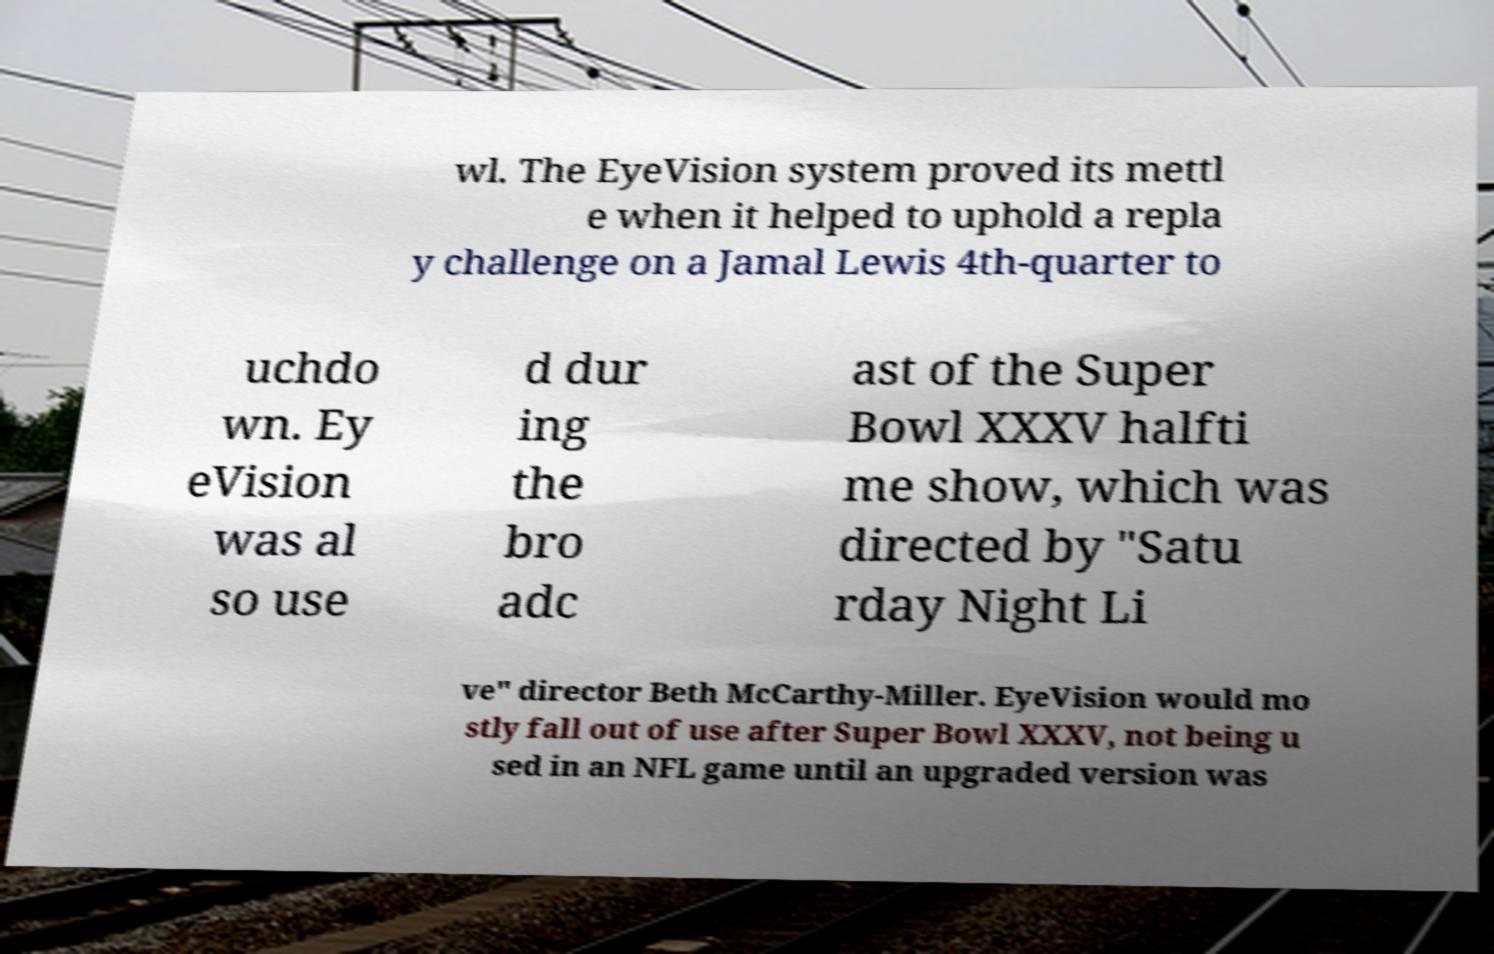Could you extract and type out the text from this image? wl. The EyeVision system proved its mettl e when it helped to uphold a repla y challenge on a Jamal Lewis 4th-quarter to uchdo wn. Ey eVision was al so use d dur ing the bro adc ast of the Super Bowl XXXV halfti me show, which was directed by "Satu rday Night Li ve" director Beth McCarthy-Miller. EyeVision would mo stly fall out of use after Super Bowl XXXV, not being u sed in an NFL game until an upgraded version was 